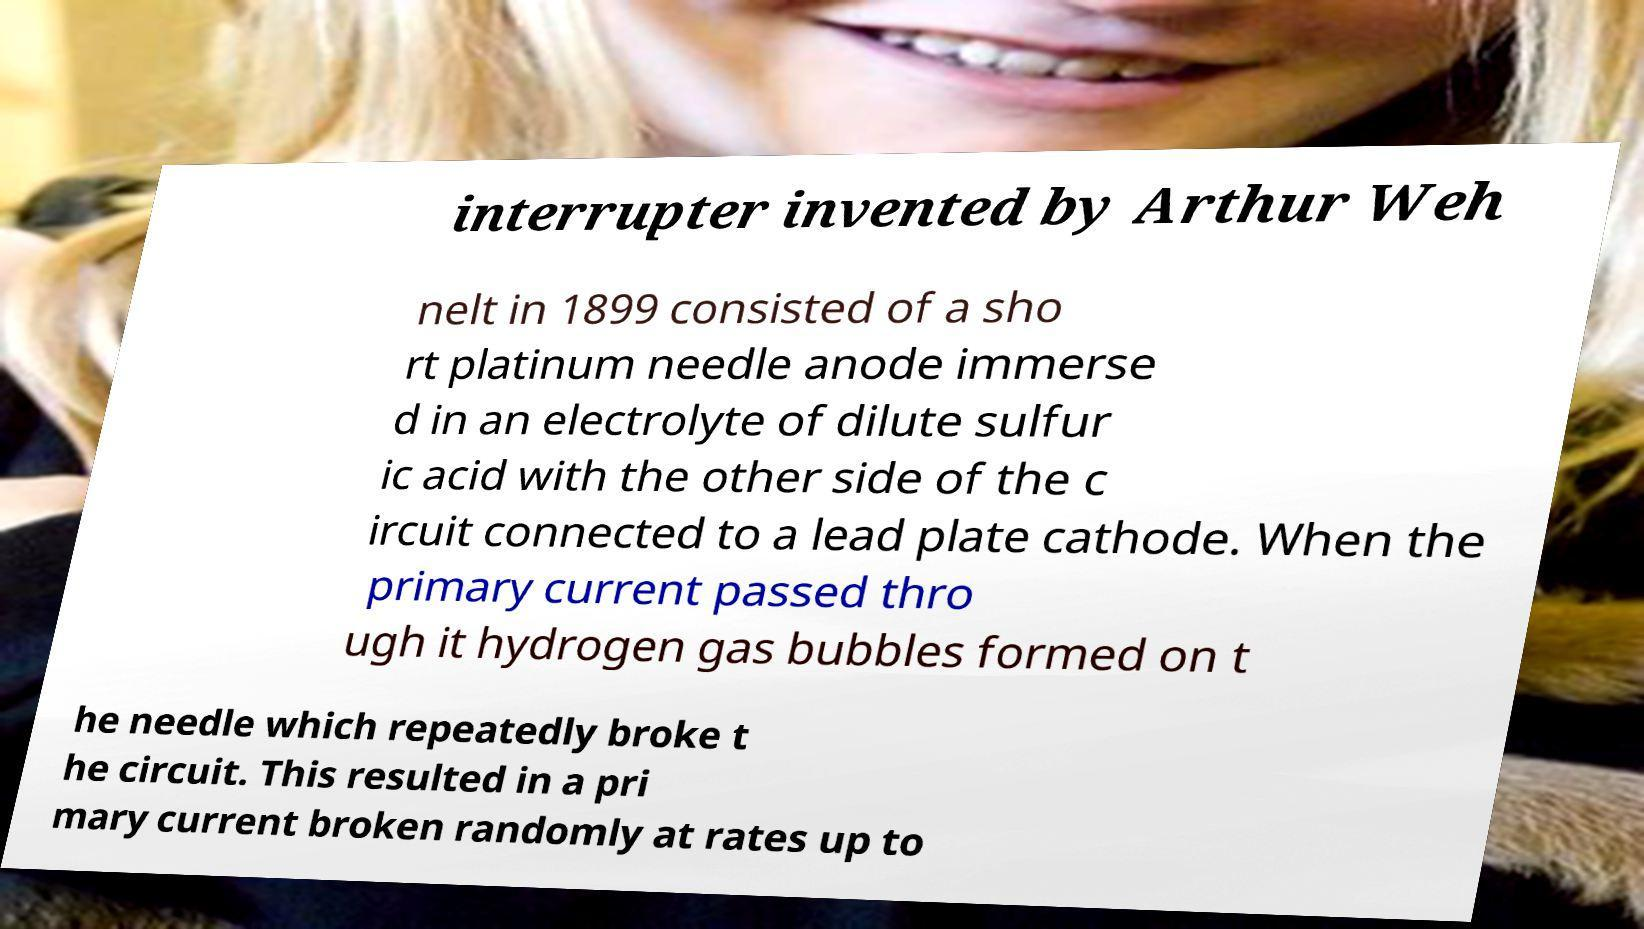Please identify and transcribe the text found in this image. interrupter invented by Arthur Weh nelt in 1899 consisted of a sho rt platinum needle anode immerse d in an electrolyte of dilute sulfur ic acid with the other side of the c ircuit connected to a lead plate cathode. When the primary current passed thro ugh it hydrogen gas bubbles formed on t he needle which repeatedly broke t he circuit. This resulted in a pri mary current broken randomly at rates up to 